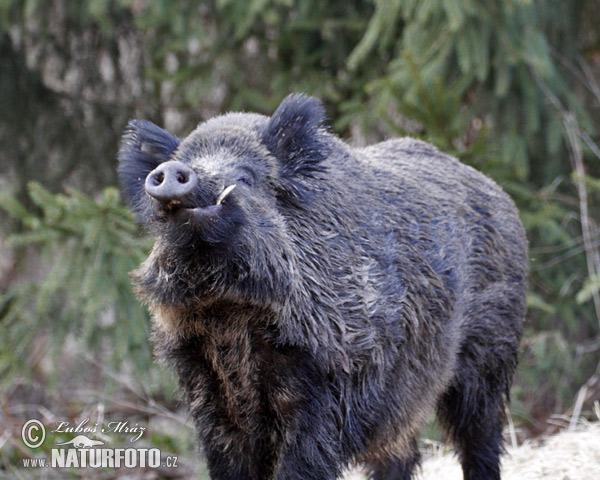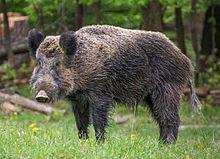The first image is the image on the left, the second image is the image on the right. For the images displayed, is the sentence "There are exactly three animals." factually correct? Answer yes or no. No. 